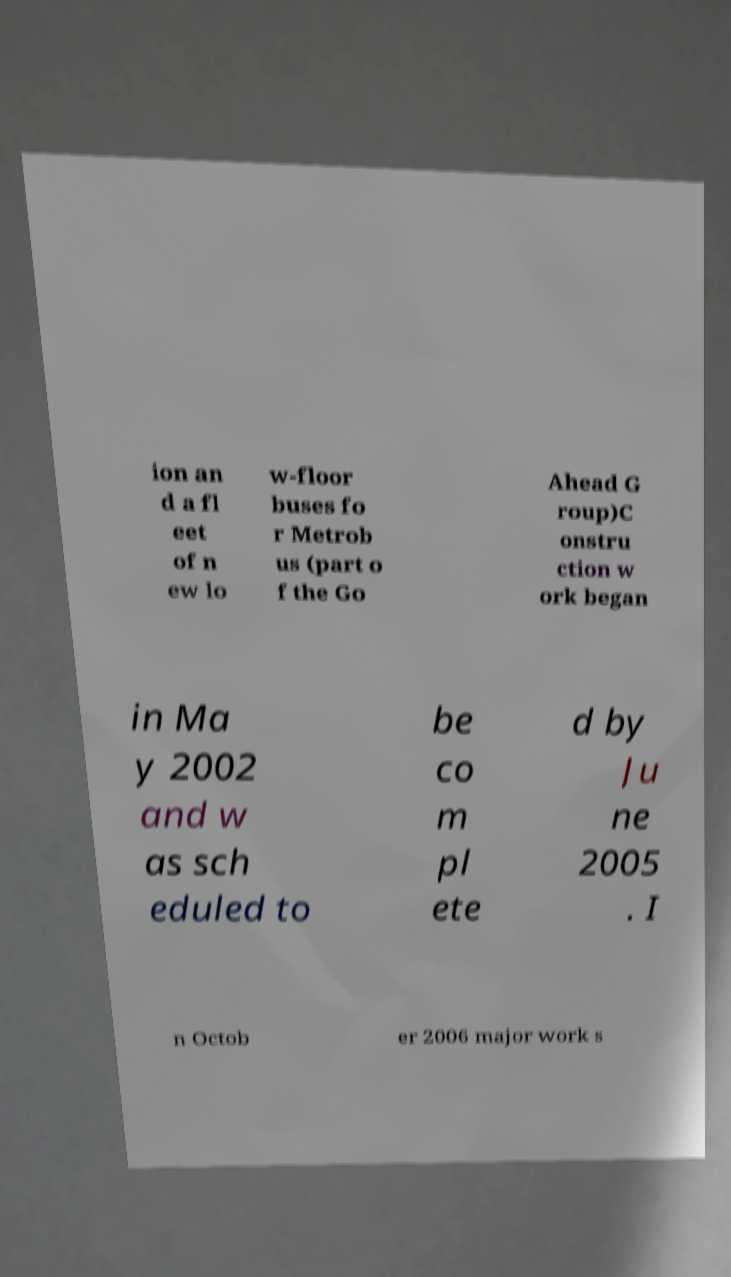What messages or text are displayed in this image? I need them in a readable, typed format. ion an d a fl eet of n ew lo w-floor buses fo r Metrob us (part o f the Go Ahead G roup)C onstru ction w ork began in Ma y 2002 and w as sch eduled to be co m pl ete d by Ju ne 2005 . I n Octob er 2006 major work s 